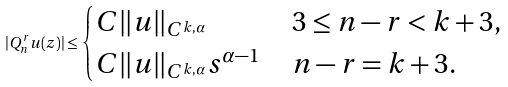<formula> <loc_0><loc_0><loc_500><loc_500>| Q _ { n } ^ { r } u ( z ) | \leq \begin{cases} C \| u \| _ { C ^ { k , \alpha } } & \, 3 \leq n - r < k + 3 , \\ C \| u \| _ { C ^ { k , \alpha } } s ^ { \alpha - 1 } & \, n - r = k + 3 . \end{cases}</formula> 